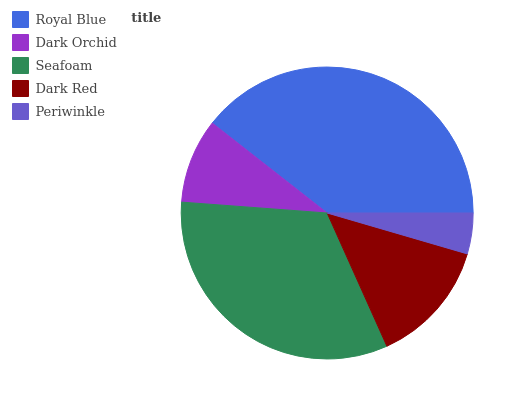Is Periwinkle the minimum?
Answer yes or no. Yes. Is Royal Blue the maximum?
Answer yes or no. Yes. Is Dark Orchid the minimum?
Answer yes or no. No. Is Dark Orchid the maximum?
Answer yes or no. No. Is Royal Blue greater than Dark Orchid?
Answer yes or no. Yes. Is Dark Orchid less than Royal Blue?
Answer yes or no. Yes. Is Dark Orchid greater than Royal Blue?
Answer yes or no. No. Is Royal Blue less than Dark Orchid?
Answer yes or no. No. Is Dark Red the high median?
Answer yes or no. Yes. Is Dark Red the low median?
Answer yes or no. Yes. Is Royal Blue the high median?
Answer yes or no. No. Is Periwinkle the low median?
Answer yes or no. No. 